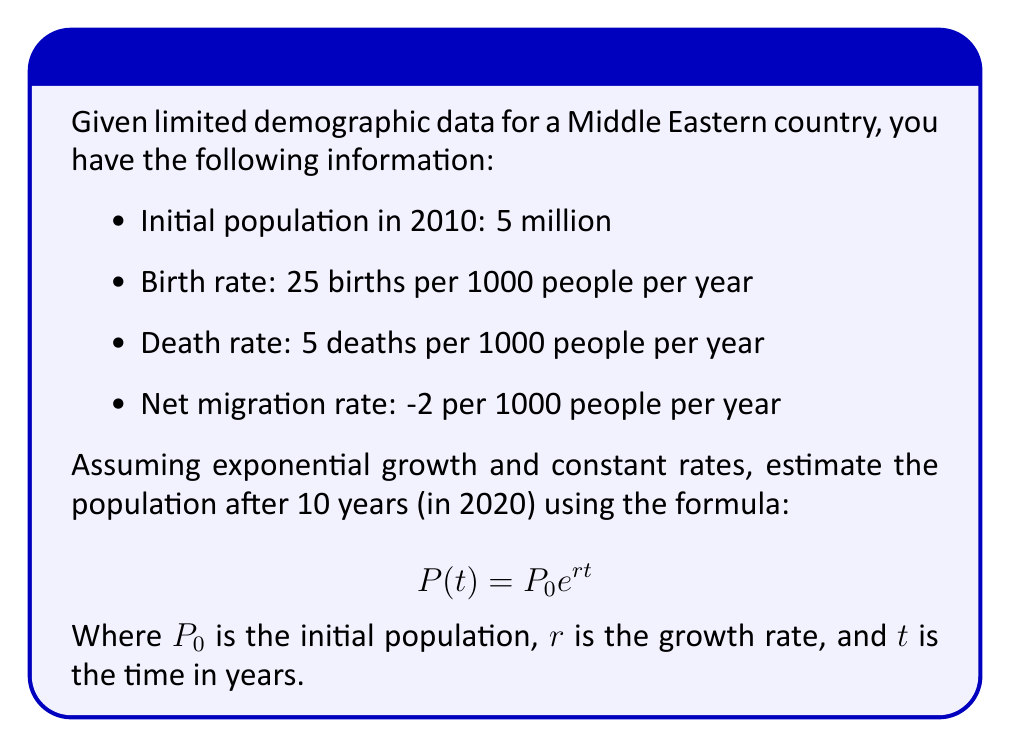Solve this math problem. To solve this inverse problem, we need to:

1. Calculate the overall growth rate:
   Birth rate: 25/1000 = 0.025
   Death rate: 5/1000 = 0.005
   Net migration rate: -2/1000 = -0.002
   
   Overall growth rate: $r = 0.025 - 0.005 - 0.002 = 0.018$ or 1.8% per year

2. Use the exponential growth formula:
   $P(t) = P_0 e^{rt}$
   
   Where:
   $P_0 = 5,000,000$ (initial population)
   $r = 0.018$ (growth rate)
   $t = 10$ (years)

3. Plug in the values:
   $P(10) = 5,000,000 \cdot e^{0.018 \cdot 10}$

4. Calculate:
   $P(10) = 5,000,000 \cdot e^{0.18}$
   $P(10) = 5,000,000 \cdot 1.1972$
   $P(10) = 5,985,994$

5. Round to the nearest thousand:
   Estimated population in 2020: 5,986,000
Answer: 5,986,000 